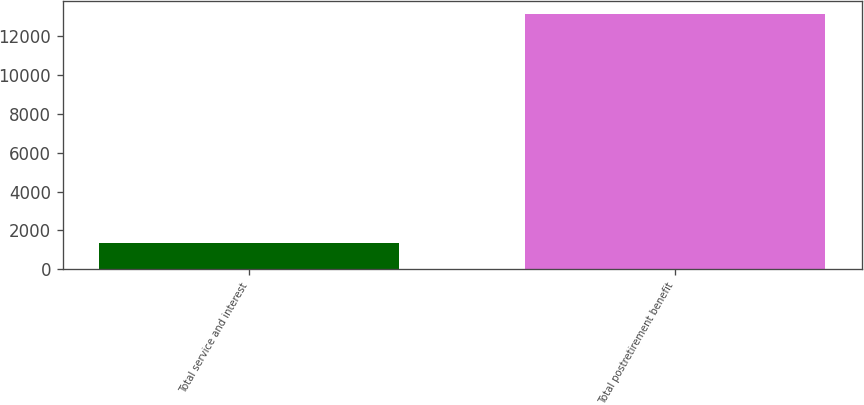Convert chart. <chart><loc_0><loc_0><loc_500><loc_500><bar_chart><fcel>Total service and interest<fcel>Total postretirement benefit<nl><fcel>1353<fcel>13160<nl></chart> 